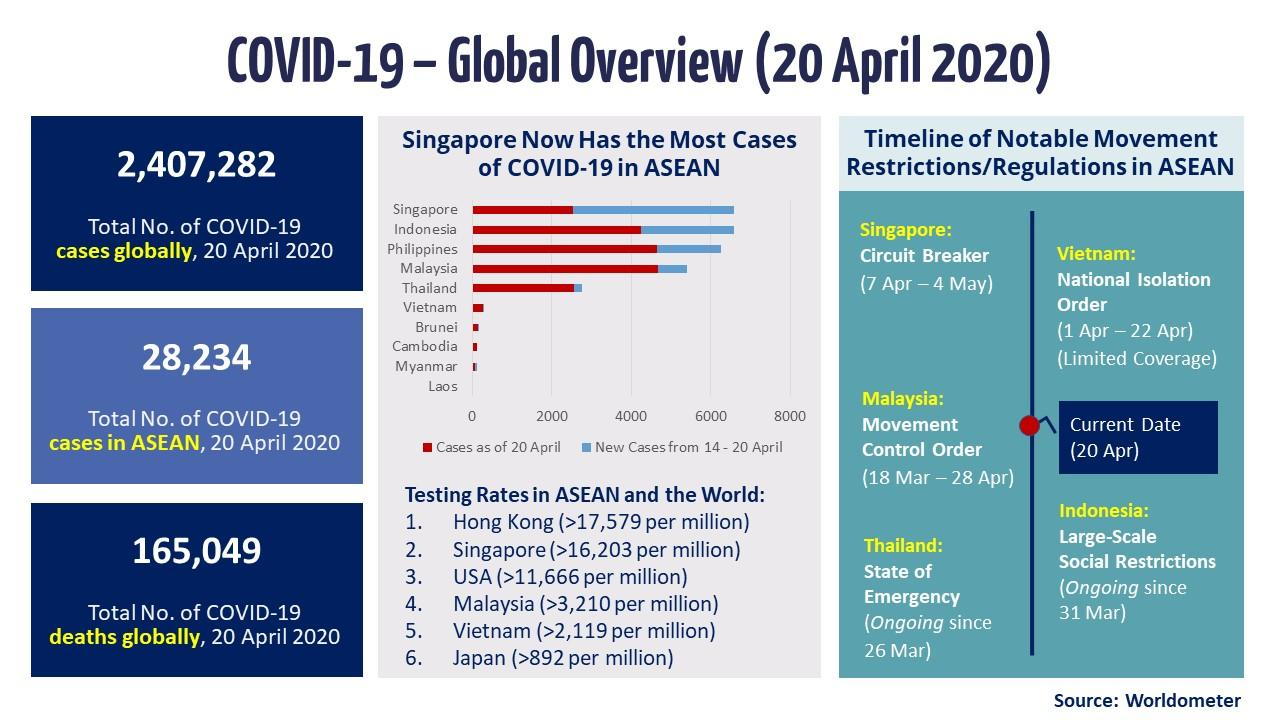Specify some key components in this picture. On March 18th, 2020, the Malaysian government implemented the movement control order as a preventive measure in response to the COVID-19 pandemic. The order remained in effect until April 28th, 2020. As of 20 April 2020, globally there have been a total of 2,407,282 confirmed cases of COVID-19. As of April 20, 2020, the total number of COVID-19 cases in ASEAN was 28,234. The 2020 Singapore circuit breaker measures were implemented as a preventive measure in response to the COVID-19 pandemic from April 7 to May 4. As of 20 April 2020, the total number of COVID-19 deaths globally was 165,049. 